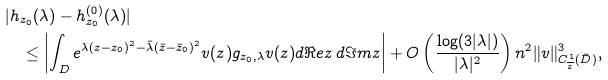Convert formula to latex. <formula><loc_0><loc_0><loc_500><loc_500>& | h _ { z _ { 0 } } ( \lambda ) - h ^ { ( 0 ) } _ { z _ { 0 } } ( \lambda ) | \\ & \quad \leq \left | \int _ { D } e ^ { \lambda ( z - z _ { 0 } ) ^ { 2 } - \bar { \lambda } ( \bar { z } - \bar { z } _ { 0 } ) ^ { 2 } } v ( z ) g _ { z _ { 0 } , \lambda } v ( z ) d \Re e z \, d \Im m z \right | + O \left ( \frac { \log ( 3 | \lambda | ) } { | \lambda | ^ { 2 } } \right ) n ^ { 2 } \| v \| ^ { 3 } _ { C ^ { 1 } _ { \overline { z } } ( \bar { D } ) } ,</formula> 